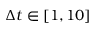Convert formula to latex. <formula><loc_0><loc_0><loc_500><loc_500>\Delta t \in [ 1 , 1 0 ]</formula> 